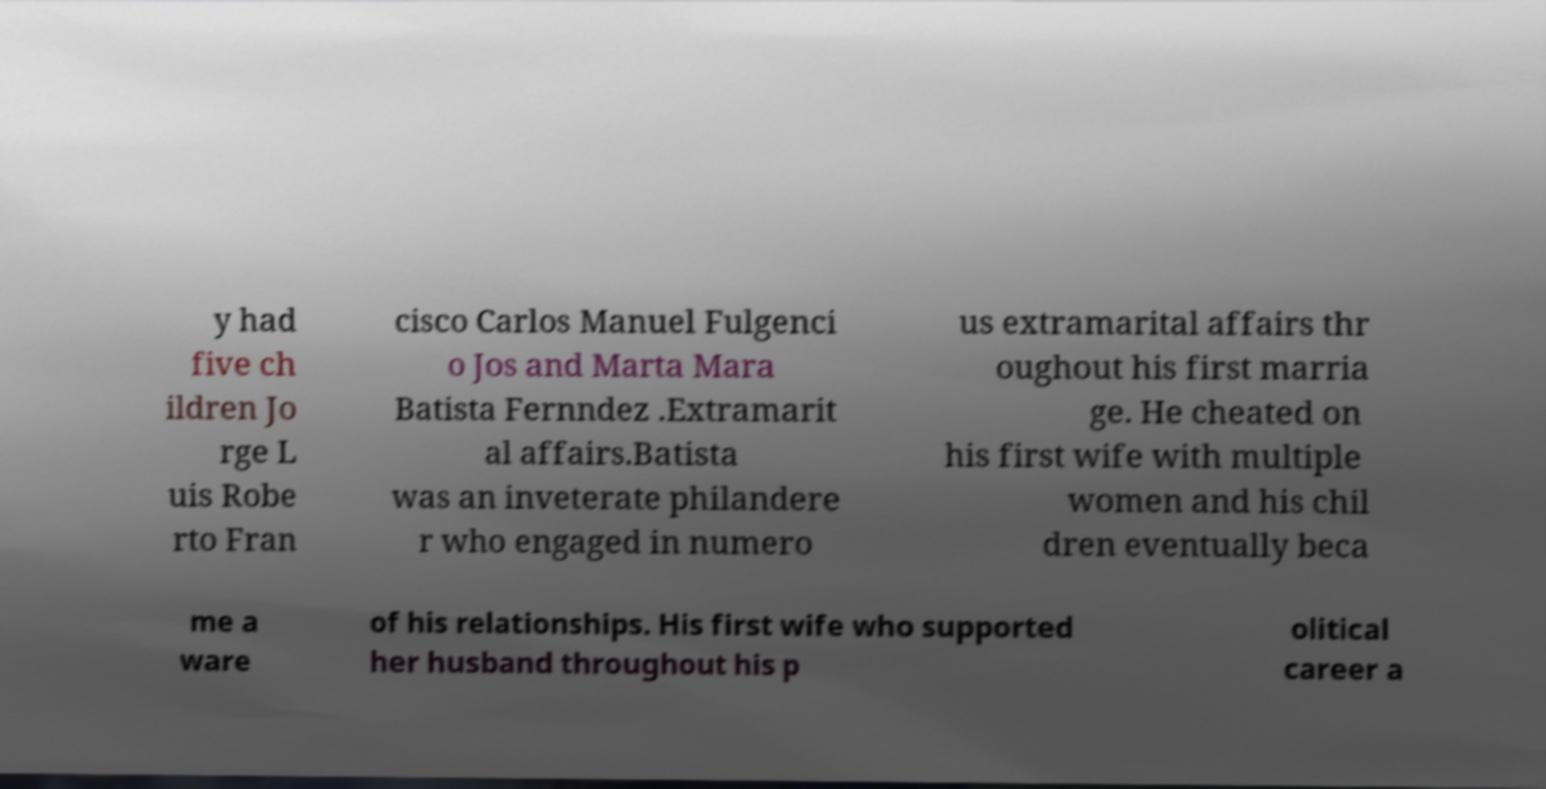There's text embedded in this image that I need extracted. Can you transcribe it verbatim? y had five ch ildren Jo rge L uis Robe rto Fran cisco Carlos Manuel Fulgenci o Jos and Marta Mara Batista Fernndez .Extramarit al affairs.Batista was an inveterate philandere r who engaged in numero us extramarital affairs thr oughout his first marria ge. He cheated on his first wife with multiple women and his chil dren eventually beca me a ware of his relationships. His first wife who supported her husband throughout his p olitical career a 